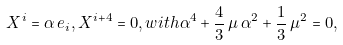<formula> <loc_0><loc_0><loc_500><loc_500>X ^ { i } = \alpha \, e _ { i } , X ^ { i + 4 } = 0 , w i t h \alpha ^ { 4 } + \frac { 4 } { 3 } \, \mu \, \alpha ^ { 2 } + \frac { 1 } { 3 } \, \mu ^ { 2 } = 0 ,</formula> 